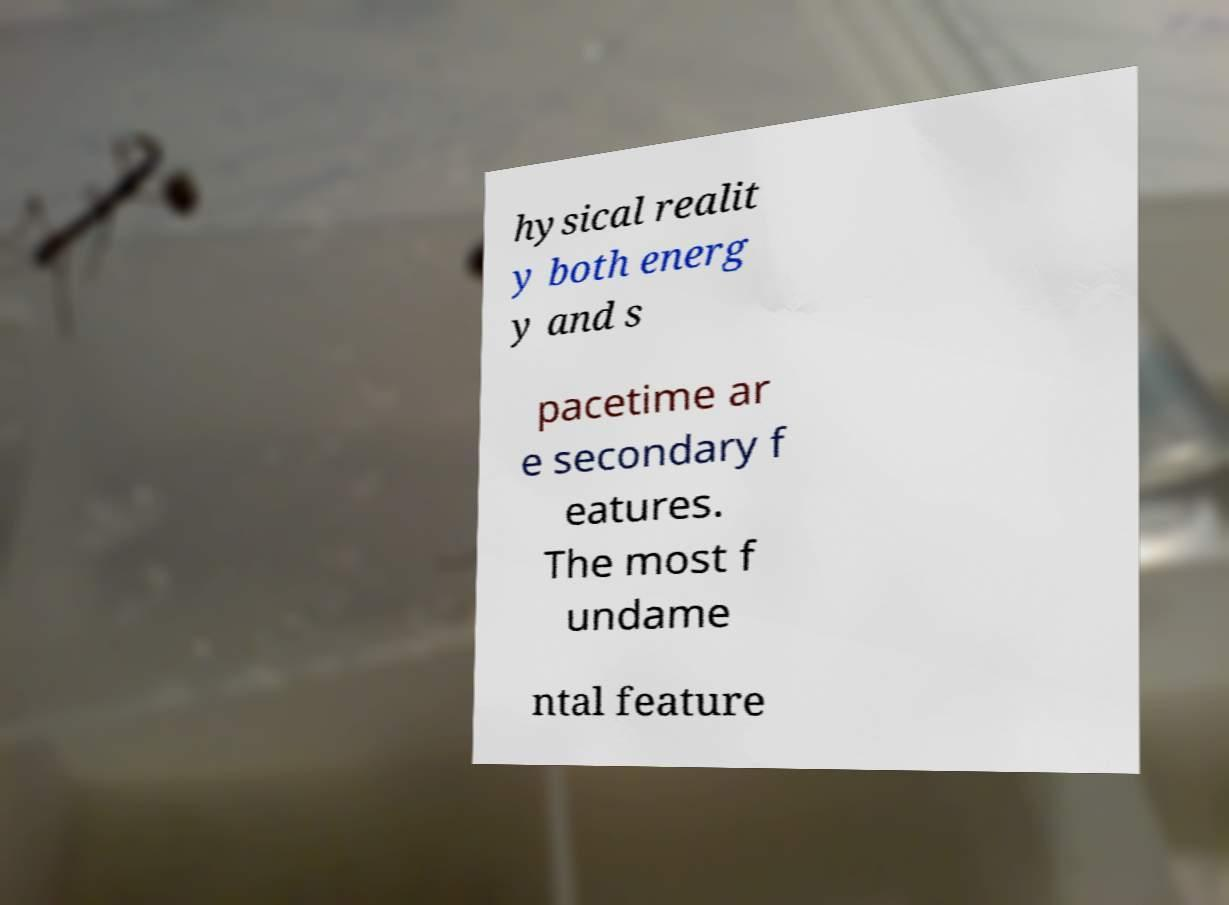Can you read and provide the text displayed in the image?This photo seems to have some interesting text. Can you extract and type it out for me? hysical realit y both energ y and s pacetime ar e secondary f eatures. The most f undame ntal feature 